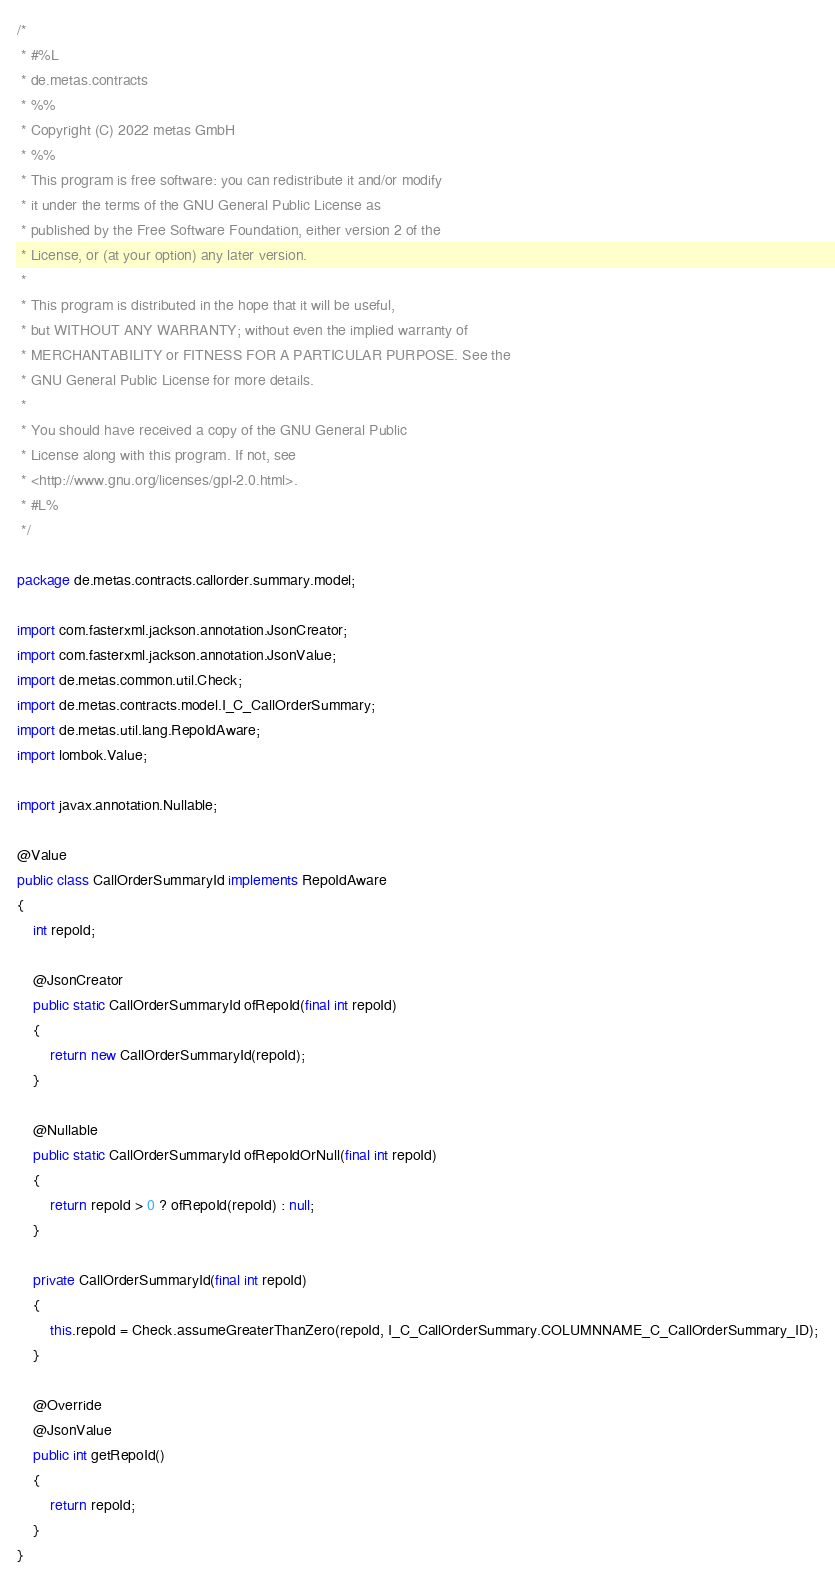Convert code to text. <code><loc_0><loc_0><loc_500><loc_500><_Java_>/*
 * #%L
 * de.metas.contracts
 * %%
 * Copyright (C) 2022 metas GmbH
 * %%
 * This program is free software: you can redistribute it and/or modify
 * it under the terms of the GNU General Public License as
 * published by the Free Software Foundation, either version 2 of the
 * License, or (at your option) any later version.
 *
 * This program is distributed in the hope that it will be useful,
 * but WITHOUT ANY WARRANTY; without even the implied warranty of
 * MERCHANTABILITY or FITNESS FOR A PARTICULAR PURPOSE. See the
 * GNU General Public License for more details.
 *
 * You should have received a copy of the GNU General Public
 * License along with this program. If not, see
 * <http://www.gnu.org/licenses/gpl-2.0.html>.
 * #L%
 */

package de.metas.contracts.callorder.summary.model;

import com.fasterxml.jackson.annotation.JsonCreator;
import com.fasterxml.jackson.annotation.JsonValue;
import de.metas.common.util.Check;
import de.metas.contracts.model.I_C_CallOrderSummary;
import de.metas.util.lang.RepoIdAware;
import lombok.Value;

import javax.annotation.Nullable;

@Value
public class CallOrderSummaryId implements RepoIdAware
{
	int repoId;

	@JsonCreator
	public static CallOrderSummaryId ofRepoId(final int repoId)
	{
		return new CallOrderSummaryId(repoId);
	}

	@Nullable
	public static CallOrderSummaryId ofRepoIdOrNull(final int repoId)
	{
		return repoId > 0 ? ofRepoId(repoId) : null;
	}

	private CallOrderSummaryId(final int repoId)
	{
		this.repoId = Check.assumeGreaterThanZero(repoId, I_C_CallOrderSummary.COLUMNNAME_C_CallOrderSummary_ID);
	}

	@Override
	@JsonValue
	public int getRepoId()
	{
		return repoId;
	}
}
</code> 